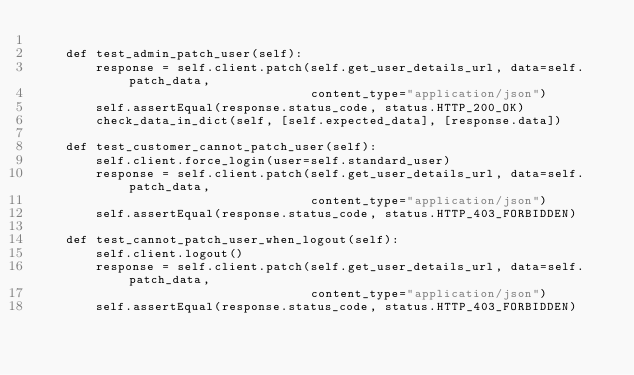<code> <loc_0><loc_0><loc_500><loc_500><_Python_>
    def test_admin_patch_user(self):
        response = self.client.patch(self.get_user_details_url, data=self.patch_data,
                                     content_type="application/json")
        self.assertEqual(response.status_code, status.HTTP_200_OK)
        check_data_in_dict(self, [self.expected_data], [response.data])

    def test_customer_cannot_patch_user(self):
        self.client.force_login(user=self.standard_user)
        response = self.client.patch(self.get_user_details_url, data=self.patch_data,
                                     content_type="application/json")
        self.assertEqual(response.status_code, status.HTTP_403_FORBIDDEN)

    def test_cannot_patch_user_when_logout(self):
        self.client.logout()
        response = self.client.patch(self.get_user_details_url, data=self.patch_data,
                                     content_type="application/json")
        self.assertEqual(response.status_code, status.HTTP_403_FORBIDDEN)
</code> 